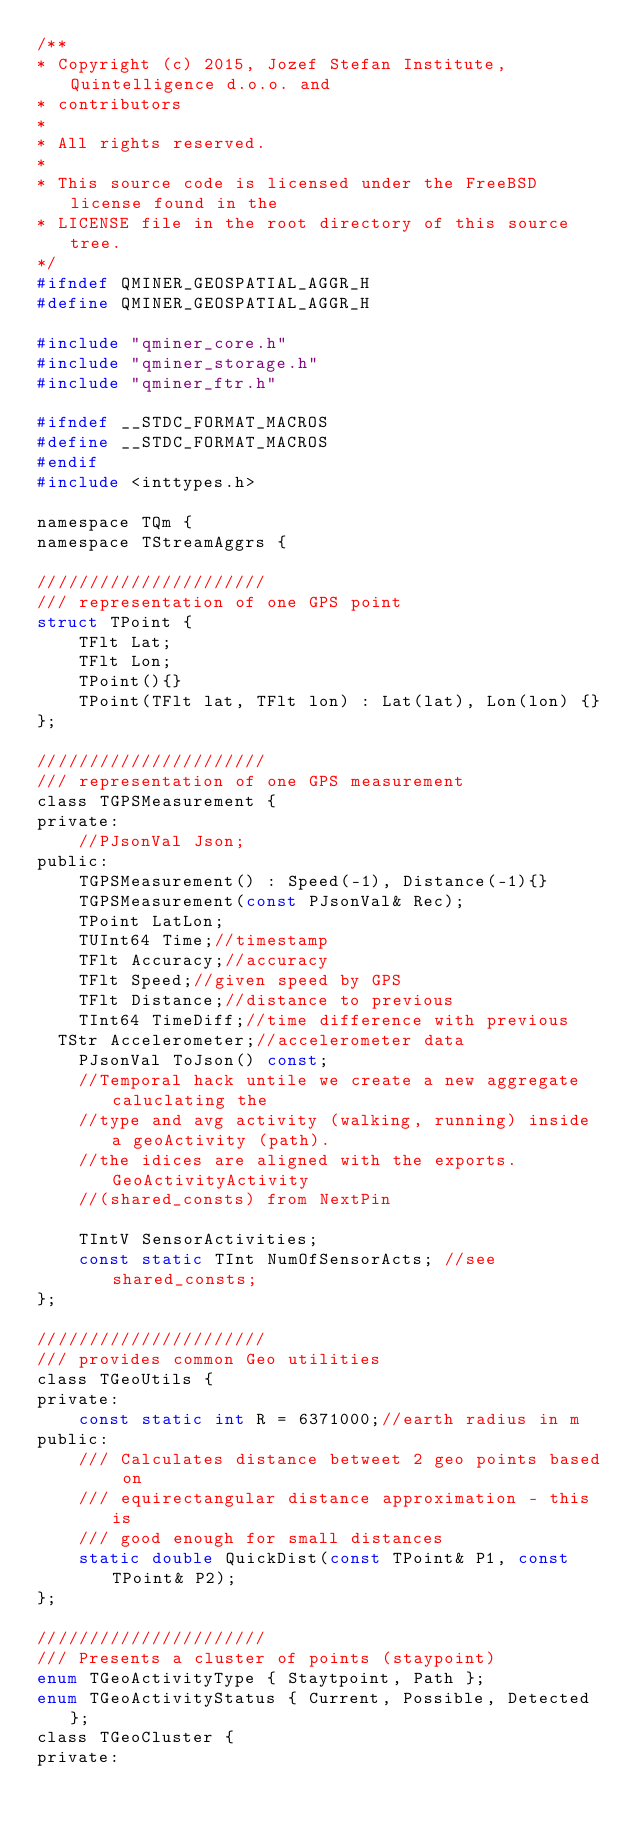<code> <loc_0><loc_0><loc_500><loc_500><_C_>/**
* Copyright (c) 2015, Jozef Stefan Institute, Quintelligence d.o.o. and
* contributors
*
* All rights reserved.
*
* This source code is licensed under the FreeBSD license found in the
* LICENSE file in the root directory of this source tree.
*/
#ifndef QMINER_GEOSPATIAL_AGGR_H
#define QMINER_GEOSPATIAL_AGGR_H

#include "qminer_core.h"
#include "qminer_storage.h"
#include "qminer_ftr.h"

#ifndef __STDC_FORMAT_MACROS
#define __STDC_FORMAT_MACROS
#endif
#include <inttypes.h>

namespace TQm {
namespace TStreamAggrs {

//////////////////////
/// representation of one GPS point
struct TPoint {
    TFlt Lat;
    TFlt Lon;
    TPoint(){}
    TPoint(TFlt lat, TFlt lon) : Lat(lat), Lon(lon) {}
};

//////////////////////
/// representation of one GPS measurement
class TGPSMeasurement {
private:
    //PJsonVal Json;
public:
    TGPSMeasurement() : Speed(-1), Distance(-1){}
    TGPSMeasurement(const PJsonVal& Rec);
    TPoint LatLon;
    TUInt64 Time;//timestamp
    TFlt Accuracy;//accuracy
    TFlt Speed;//given speed by GPS
    TFlt Distance;//distance to previous
    TInt64 TimeDiff;//time difference with previous
	TStr Accelerometer;//accelerometer data
    PJsonVal ToJson() const;
    //Temporal hack untile we create a new aggregate caluclating the
    //type and avg activity (walking, running) inside a geoActivity (path).
    //the idices are aligned with the exports.GeoActivityActivity
    //(shared_consts) from NextPin

    TIntV SensorActivities;
    const static TInt NumOfSensorActs; //see shared_consts;
};

//////////////////////
/// provides common Geo utilities
class TGeoUtils {
private:
    const static int R = 6371000;//earth radius in m
public:
    /// Calculates distance betweet 2 geo points based on
    /// equirectangular distance approximation - this is
    /// good enough for small distances
    static double QuickDist(const TPoint& P1, const TPoint& P2);
};

//////////////////////
/// Presents a cluster of points (staypoint)
enum TGeoActivityType { Staytpoint, Path };
enum TGeoActivityStatus { Current, Possible, Detected };
class TGeoCluster {
private:</code> 